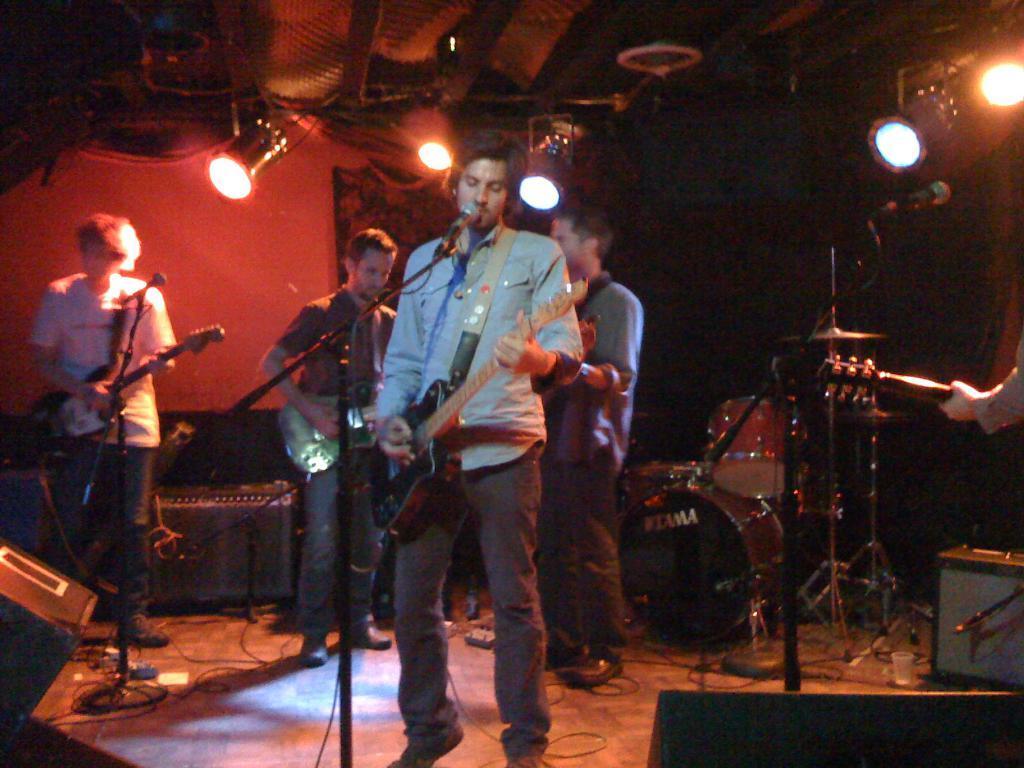Describe this image in one or two sentences. In this image we can see a few people playing the guitars, there are some other musical instruments on the stage, also we can see some stands and mics, at the top of the roof we can see some lights and there is a poster on the wall. 